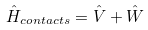<formula> <loc_0><loc_0><loc_500><loc_500>\hat { H } _ { c o n t a c t s } = \hat { V } + \hat { W }</formula> 